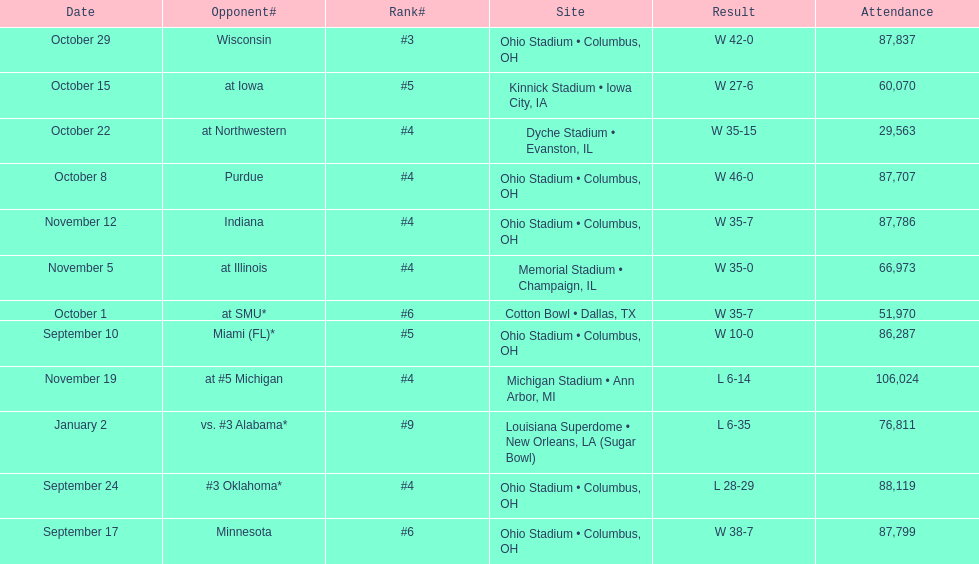How many games did this team win during this season? 9. 